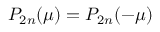<formula> <loc_0><loc_0><loc_500><loc_500>P _ { 2 n } ( \mu ) = P _ { 2 n } ( - \mu )</formula> 